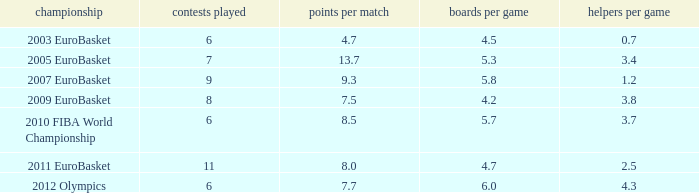How may assists per game have 7.7 points per game? 4.3. 